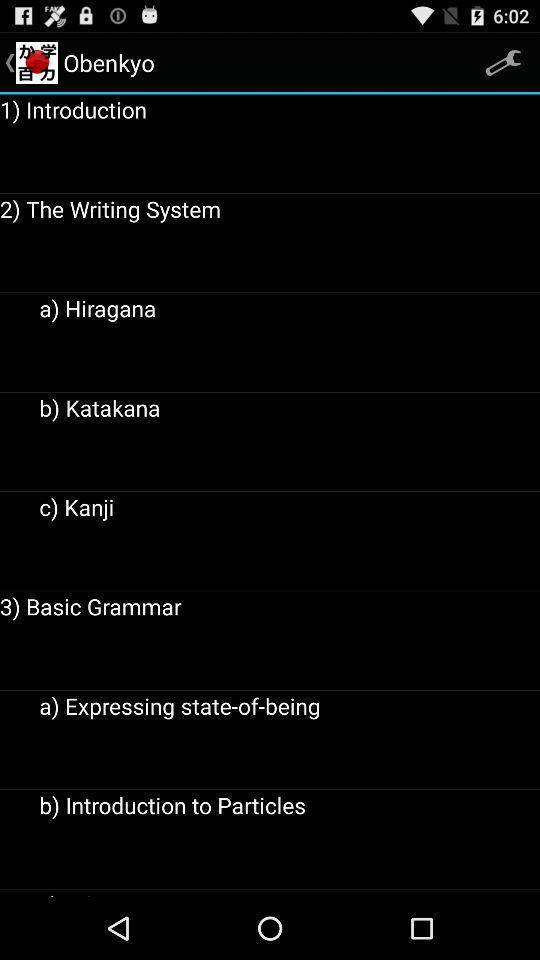What are the subheadings in "Basic Grammar"? The subheadings are "Expressing state-of-being" and "Introduction to Particles". 